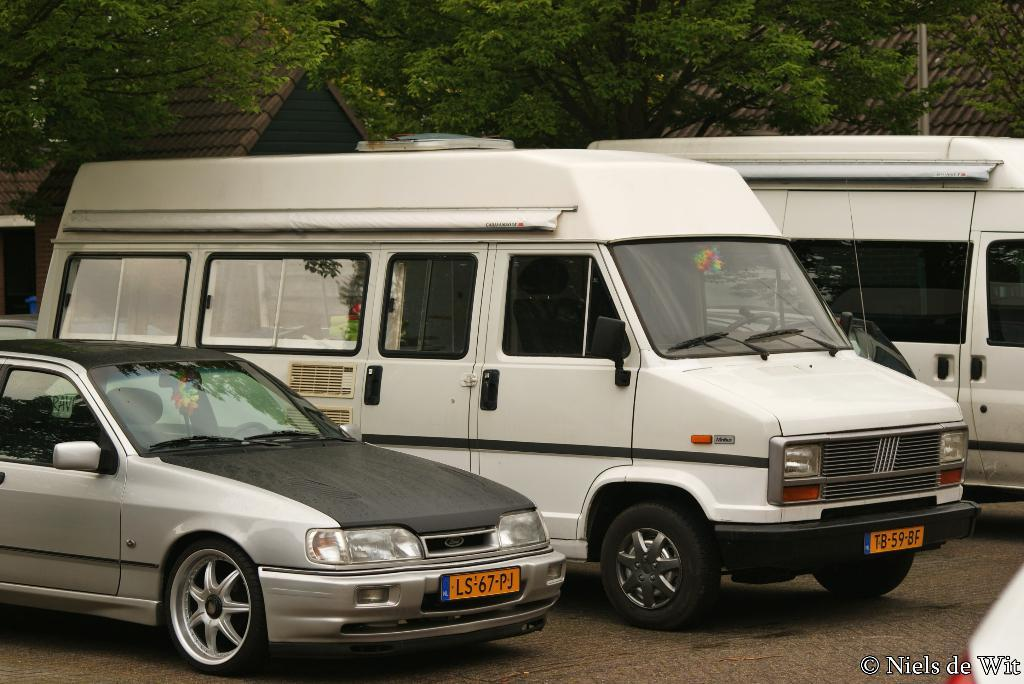<image>
Create a compact narrative representing the image presented. A silver sedan with a license plate of LS-67-PJ next to a white van with the license plate TB-59-BF. 